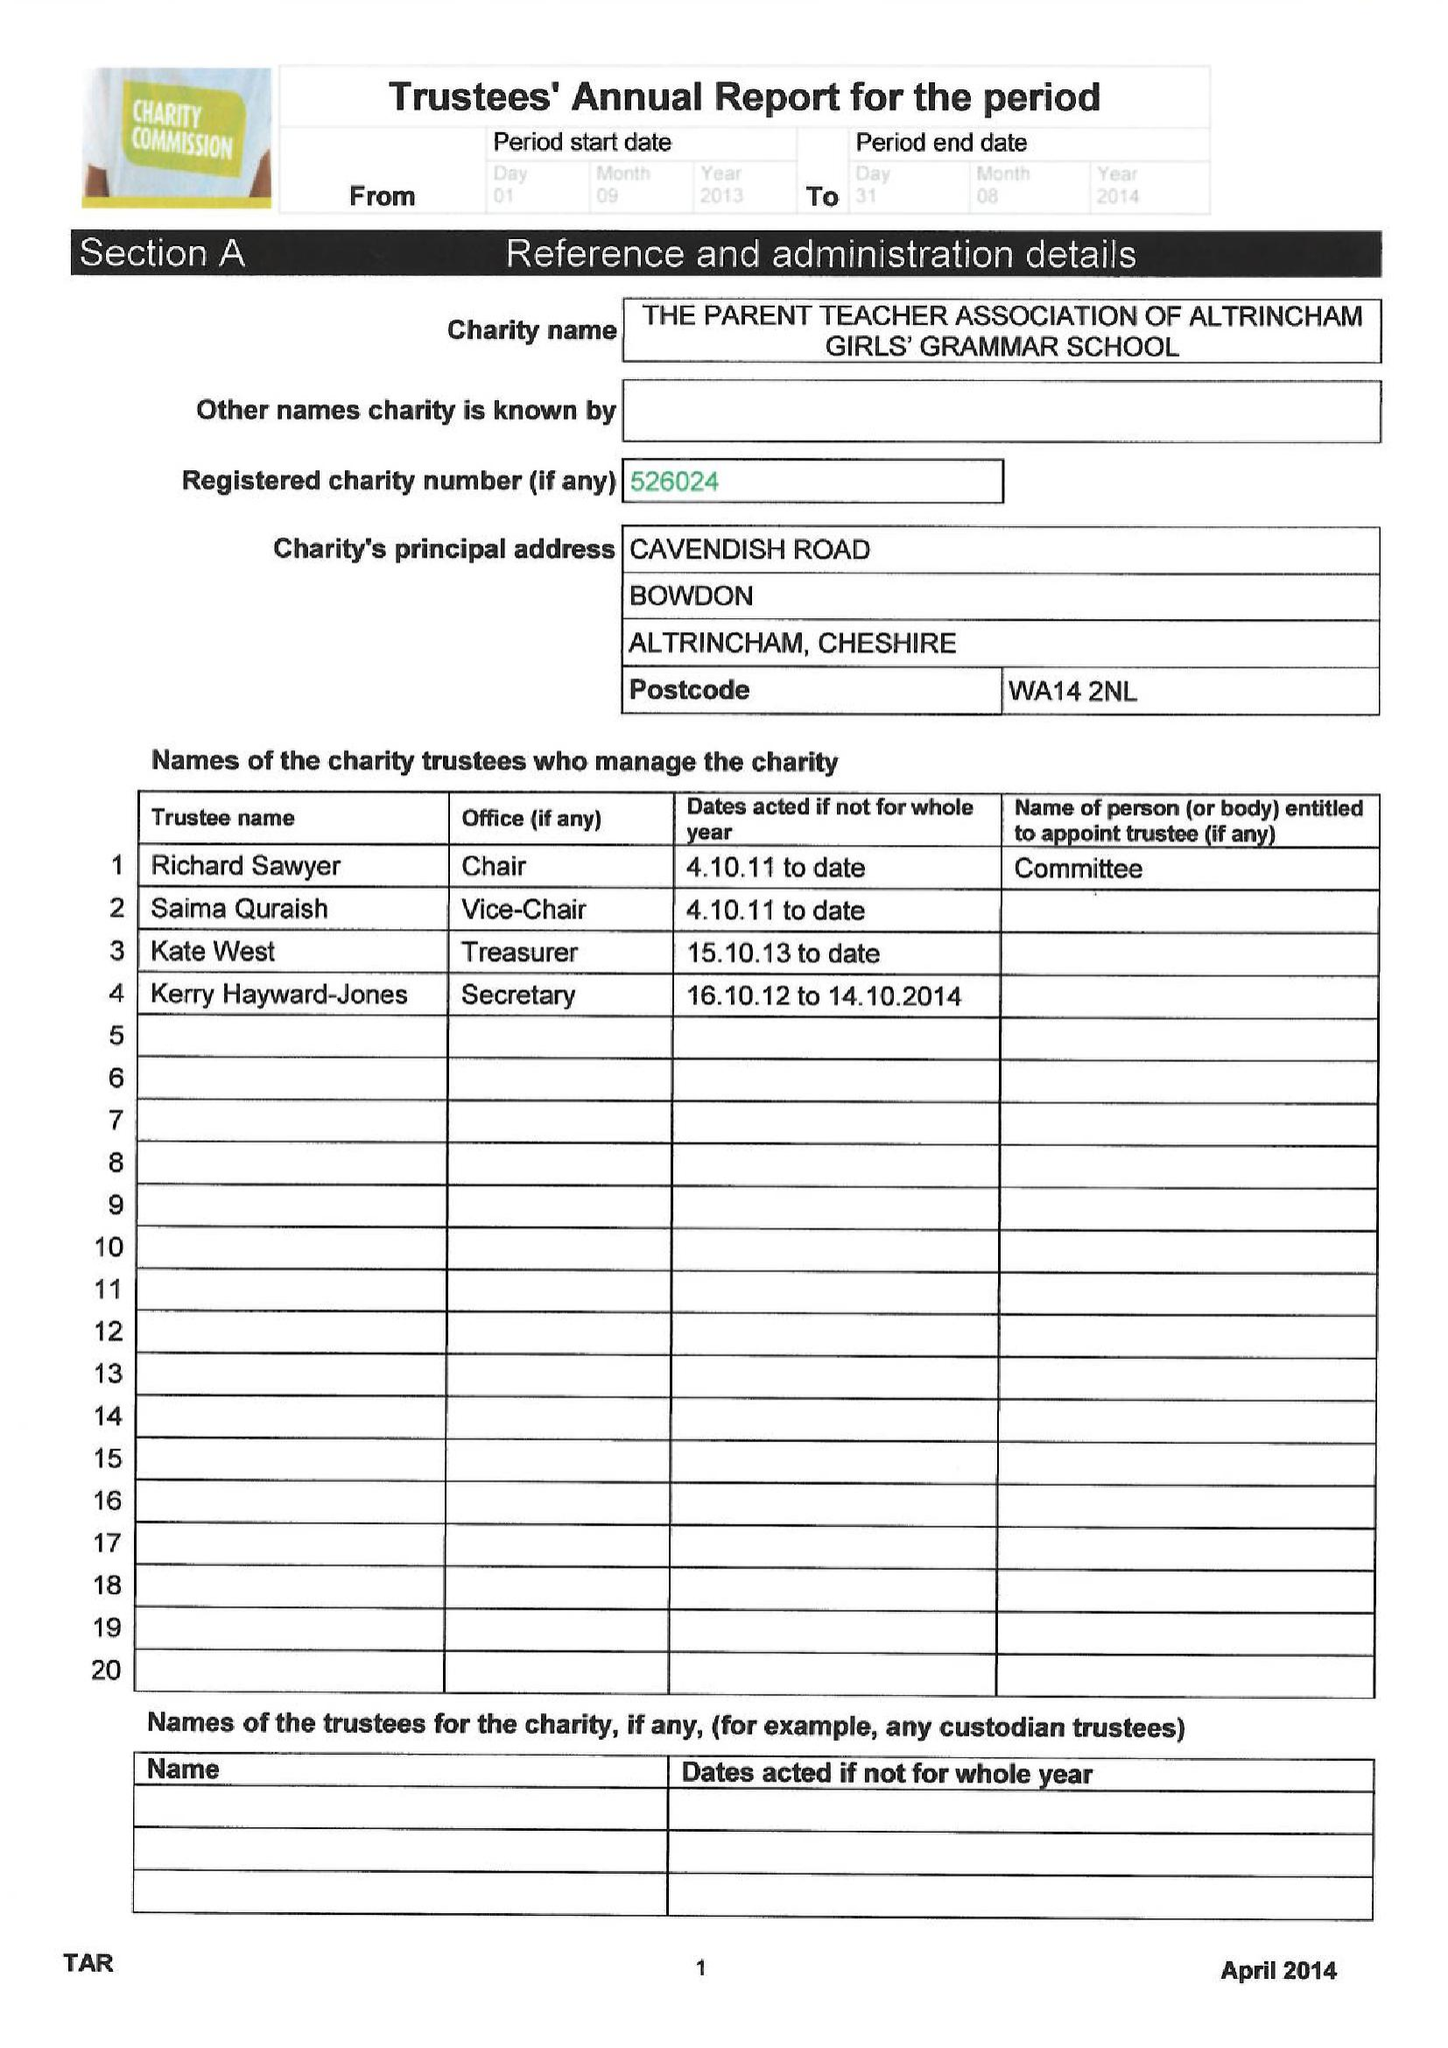What is the value for the address__post_town?
Answer the question using a single word or phrase. ALTRINCHAM 